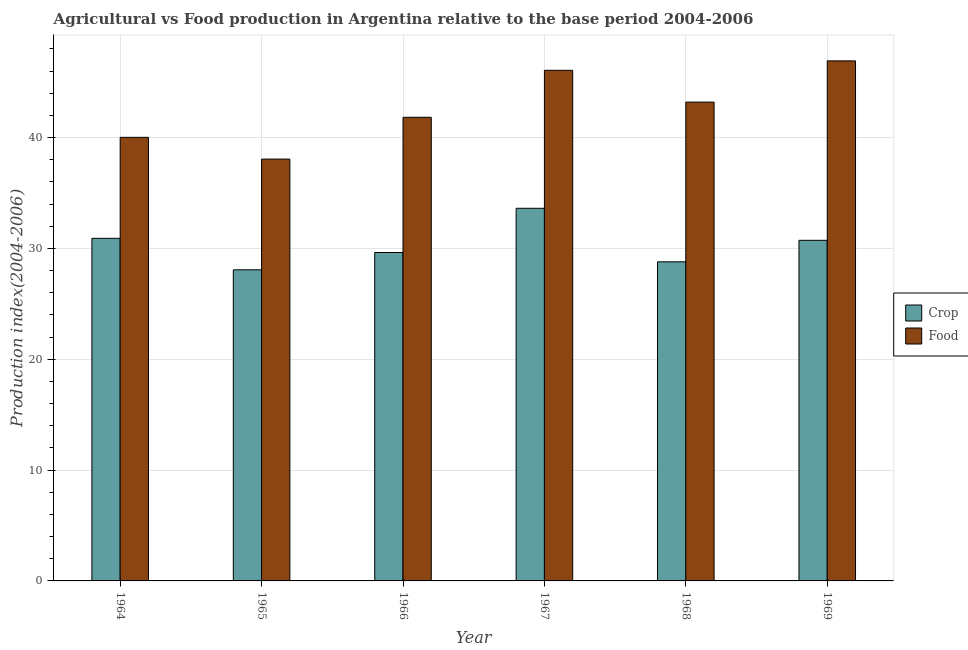Are the number of bars per tick equal to the number of legend labels?
Make the answer very short. Yes. How many bars are there on the 1st tick from the right?
Ensure brevity in your answer.  2. What is the label of the 1st group of bars from the left?
Give a very brief answer. 1964. What is the food production index in 1966?
Offer a very short reply. 41.83. Across all years, what is the maximum crop production index?
Ensure brevity in your answer.  33.62. Across all years, what is the minimum crop production index?
Provide a short and direct response. 28.07. In which year was the crop production index maximum?
Your response must be concise. 1967. In which year was the crop production index minimum?
Provide a succinct answer. 1965. What is the total crop production index in the graph?
Your answer should be compact. 181.75. What is the difference between the food production index in 1967 and that in 1969?
Keep it short and to the point. -0.85. What is the difference between the food production index in 1964 and the crop production index in 1965?
Offer a very short reply. 1.96. What is the average food production index per year?
Ensure brevity in your answer.  42.68. In the year 1968, what is the difference between the food production index and crop production index?
Your answer should be very brief. 0. What is the ratio of the food production index in 1968 to that in 1969?
Offer a terse response. 0.92. Is the difference between the crop production index in 1966 and 1968 greater than the difference between the food production index in 1966 and 1968?
Give a very brief answer. No. What is the difference between the highest and the second highest food production index?
Provide a succinct answer. 0.85. What is the difference between the highest and the lowest food production index?
Provide a succinct answer. 8.86. Is the sum of the food production index in 1964 and 1966 greater than the maximum crop production index across all years?
Your response must be concise. Yes. What does the 1st bar from the left in 1968 represents?
Your answer should be compact. Crop. What does the 1st bar from the right in 1967 represents?
Offer a terse response. Food. Are all the bars in the graph horizontal?
Make the answer very short. No. How many years are there in the graph?
Offer a terse response. 6. What is the difference between two consecutive major ticks on the Y-axis?
Give a very brief answer. 10. Are the values on the major ticks of Y-axis written in scientific E-notation?
Give a very brief answer. No. Does the graph contain grids?
Provide a short and direct response. Yes. What is the title of the graph?
Your response must be concise. Agricultural vs Food production in Argentina relative to the base period 2004-2006. What is the label or title of the X-axis?
Your answer should be compact. Year. What is the label or title of the Y-axis?
Provide a short and direct response. Production index(2004-2006). What is the Production index(2004-2006) in Crop in 1964?
Give a very brief answer. 30.91. What is the Production index(2004-2006) in Food in 1964?
Provide a short and direct response. 40.02. What is the Production index(2004-2006) of Crop in 1965?
Your answer should be very brief. 28.07. What is the Production index(2004-2006) in Food in 1965?
Your answer should be compact. 38.06. What is the Production index(2004-2006) of Crop in 1966?
Ensure brevity in your answer.  29.63. What is the Production index(2004-2006) of Food in 1966?
Provide a succinct answer. 41.83. What is the Production index(2004-2006) of Crop in 1967?
Offer a terse response. 33.62. What is the Production index(2004-2006) in Food in 1967?
Your answer should be very brief. 46.07. What is the Production index(2004-2006) of Crop in 1968?
Your response must be concise. 28.79. What is the Production index(2004-2006) in Food in 1968?
Keep it short and to the point. 43.2. What is the Production index(2004-2006) of Crop in 1969?
Offer a very short reply. 30.73. What is the Production index(2004-2006) of Food in 1969?
Your response must be concise. 46.92. Across all years, what is the maximum Production index(2004-2006) of Crop?
Make the answer very short. 33.62. Across all years, what is the maximum Production index(2004-2006) in Food?
Ensure brevity in your answer.  46.92. Across all years, what is the minimum Production index(2004-2006) in Crop?
Give a very brief answer. 28.07. Across all years, what is the minimum Production index(2004-2006) of Food?
Your answer should be compact. 38.06. What is the total Production index(2004-2006) of Crop in the graph?
Your answer should be compact. 181.75. What is the total Production index(2004-2006) of Food in the graph?
Your response must be concise. 256.1. What is the difference between the Production index(2004-2006) of Crop in 1964 and that in 1965?
Your response must be concise. 2.84. What is the difference between the Production index(2004-2006) in Food in 1964 and that in 1965?
Your answer should be very brief. 1.96. What is the difference between the Production index(2004-2006) in Crop in 1964 and that in 1966?
Make the answer very short. 1.28. What is the difference between the Production index(2004-2006) in Food in 1964 and that in 1966?
Your answer should be compact. -1.81. What is the difference between the Production index(2004-2006) of Crop in 1964 and that in 1967?
Provide a succinct answer. -2.71. What is the difference between the Production index(2004-2006) of Food in 1964 and that in 1967?
Ensure brevity in your answer.  -6.05. What is the difference between the Production index(2004-2006) in Crop in 1964 and that in 1968?
Make the answer very short. 2.12. What is the difference between the Production index(2004-2006) in Food in 1964 and that in 1968?
Keep it short and to the point. -3.18. What is the difference between the Production index(2004-2006) of Crop in 1964 and that in 1969?
Your answer should be compact. 0.18. What is the difference between the Production index(2004-2006) of Food in 1964 and that in 1969?
Ensure brevity in your answer.  -6.9. What is the difference between the Production index(2004-2006) in Crop in 1965 and that in 1966?
Provide a short and direct response. -1.56. What is the difference between the Production index(2004-2006) in Food in 1965 and that in 1966?
Provide a succinct answer. -3.77. What is the difference between the Production index(2004-2006) in Crop in 1965 and that in 1967?
Ensure brevity in your answer.  -5.55. What is the difference between the Production index(2004-2006) in Food in 1965 and that in 1967?
Your answer should be very brief. -8.01. What is the difference between the Production index(2004-2006) of Crop in 1965 and that in 1968?
Make the answer very short. -0.72. What is the difference between the Production index(2004-2006) in Food in 1965 and that in 1968?
Offer a terse response. -5.14. What is the difference between the Production index(2004-2006) in Crop in 1965 and that in 1969?
Your answer should be compact. -2.66. What is the difference between the Production index(2004-2006) of Food in 1965 and that in 1969?
Keep it short and to the point. -8.86. What is the difference between the Production index(2004-2006) of Crop in 1966 and that in 1967?
Ensure brevity in your answer.  -3.99. What is the difference between the Production index(2004-2006) of Food in 1966 and that in 1967?
Your answer should be compact. -4.24. What is the difference between the Production index(2004-2006) in Crop in 1966 and that in 1968?
Keep it short and to the point. 0.84. What is the difference between the Production index(2004-2006) of Food in 1966 and that in 1968?
Your response must be concise. -1.37. What is the difference between the Production index(2004-2006) of Food in 1966 and that in 1969?
Your answer should be compact. -5.09. What is the difference between the Production index(2004-2006) in Crop in 1967 and that in 1968?
Make the answer very short. 4.83. What is the difference between the Production index(2004-2006) of Food in 1967 and that in 1968?
Provide a succinct answer. 2.87. What is the difference between the Production index(2004-2006) of Crop in 1967 and that in 1969?
Offer a terse response. 2.89. What is the difference between the Production index(2004-2006) in Food in 1967 and that in 1969?
Provide a short and direct response. -0.85. What is the difference between the Production index(2004-2006) of Crop in 1968 and that in 1969?
Offer a very short reply. -1.94. What is the difference between the Production index(2004-2006) in Food in 1968 and that in 1969?
Provide a short and direct response. -3.72. What is the difference between the Production index(2004-2006) of Crop in 1964 and the Production index(2004-2006) of Food in 1965?
Your response must be concise. -7.15. What is the difference between the Production index(2004-2006) of Crop in 1964 and the Production index(2004-2006) of Food in 1966?
Make the answer very short. -10.92. What is the difference between the Production index(2004-2006) of Crop in 1964 and the Production index(2004-2006) of Food in 1967?
Your answer should be compact. -15.16. What is the difference between the Production index(2004-2006) in Crop in 1964 and the Production index(2004-2006) in Food in 1968?
Your answer should be compact. -12.29. What is the difference between the Production index(2004-2006) of Crop in 1964 and the Production index(2004-2006) of Food in 1969?
Provide a short and direct response. -16.01. What is the difference between the Production index(2004-2006) in Crop in 1965 and the Production index(2004-2006) in Food in 1966?
Keep it short and to the point. -13.76. What is the difference between the Production index(2004-2006) of Crop in 1965 and the Production index(2004-2006) of Food in 1968?
Your answer should be compact. -15.13. What is the difference between the Production index(2004-2006) in Crop in 1965 and the Production index(2004-2006) in Food in 1969?
Make the answer very short. -18.85. What is the difference between the Production index(2004-2006) of Crop in 1966 and the Production index(2004-2006) of Food in 1967?
Your answer should be compact. -16.44. What is the difference between the Production index(2004-2006) of Crop in 1966 and the Production index(2004-2006) of Food in 1968?
Your response must be concise. -13.57. What is the difference between the Production index(2004-2006) of Crop in 1966 and the Production index(2004-2006) of Food in 1969?
Offer a very short reply. -17.29. What is the difference between the Production index(2004-2006) of Crop in 1967 and the Production index(2004-2006) of Food in 1968?
Provide a succinct answer. -9.58. What is the difference between the Production index(2004-2006) of Crop in 1968 and the Production index(2004-2006) of Food in 1969?
Offer a terse response. -18.13. What is the average Production index(2004-2006) of Crop per year?
Provide a short and direct response. 30.29. What is the average Production index(2004-2006) of Food per year?
Keep it short and to the point. 42.68. In the year 1964, what is the difference between the Production index(2004-2006) in Crop and Production index(2004-2006) in Food?
Offer a very short reply. -9.11. In the year 1965, what is the difference between the Production index(2004-2006) in Crop and Production index(2004-2006) in Food?
Offer a terse response. -9.99. In the year 1966, what is the difference between the Production index(2004-2006) in Crop and Production index(2004-2006) in Food?
Your answer should be compact. -12.2. In the year 1967, what is the difference between the Production index(2004-2006) of Crop and Production index(2004-2006) of Food?
Ensure brevity in your answer.  -12.45. In the year 1968, what is the difference between the Production index(2004-2006) of Crop and Production index(2004-2006) of Food?
Your answer should be very brief. -14.41. In the year 1969, what is the difference between the Production index(2004-2006) in Crop and Production index(2004-2006) in Food?
Provide a succinct answer. -16.19. What is the ratio of the Production index(2004-2006) in Crop in 1964 to that in 1965?
Your answer should be very brief. 1.1. What is the ratio of the Production index(2004-2006) of Food in 1964 to that in 1965?
Provide a short and direct response. 1.05. What is the ratio of the Production index(2004-2006) of Crop in 1964 to that in 1966?
Ensure brevity in your answer.  1.04. What is the ratio of the Production index(2004-2006) of Food in 1964 to that in 1966?
Ensure brevity in your answer.  0.96. What is the ratio of the Production index(2004-2006) in Crop in 1964 to that in 1967?
Offer a terse response. 0.92. What is the ratio of the Production index(2004-2006) of Food in 1964 to that in 1967?
Make the answer very short. 0.87. What is the ratio of the Production index(2004-2006) of Crop in 1964 to that in 1968?
Your answer should be compact. 1.07. What is the ratio of the Production index(2004-2006) of Food in 1964 to that in 1968?
Give a very brief answer. 0.93. What is the ratio of the Production index(2004-2006) of Crop in 1964 to that in 1969?
Ensure brevity in your answer.  1.01. What is the ratio of the Production index(2004-2006) in Food in 1964 to that in 1969?
Offer a very short reply. 0.85. What is the ratio of the Production index(2004-2006) in Food in 1965 to that in 1966?
Keep it short and to the point. 0.91. What is the ratio of the Production index(2004-2006) in Crop in 1965 to that in 1967?
Your answer should be very brief. 0.83. What is the ratio of the Production index(2004-2006) in Food in 1965 to that in 1967?
Keep it short and to the point. 0.83. What is the ratio of the Production index(2004-2006) in Food in 1965 to that in 1968?
Make the answer very short. 0.88. What is the ratio of the Production index(2004-2006) in Crop in 1965 to that in 1969?
Provide a short and direct response. 0.91. What is the ratio of the Production index(2004-2006) of Food in 1965 to that in 1969?
Make the answer very short. 0.81. What is the ratio of the Production index(2004-2006) of Crop in 1966 to that in 1967?
Make the answer very short. 0.88. What is the ratio of the Production index(2004-2006) in Food in 1966 to that in 1967?
Make the answer very short. 0.91. What is the ratio of the Production index(2004-2006) in Crop in 1966 to that in 1968?
Offer a terse response. 1.03. What is the ratio of the Production index(2004-2006) of Food in 1966 to that in 1968?
Give a very brief answer. 0.97. What is the ratio of the Production index(2004-2006) of Crop in 1966 to that in 1969?
Provide a succinct answer. 0.96. What is the ratio of the Production index(2004-2006) in Food in 1966 to that in 1969?
Provide a short and direct response. 0.89. What is the ratio of the Production index(2004-2006) of Crop in 1967 to that in 1968?
Your answer should be very brief. 1.17. What is the ratio of the Production index(2004-2006) of Food in 1967 to that in 1968?
Your answer should be compact. 1.07. What is the ratio of the Production index(2004-2006) of Crop in 1967 to that in 1969?
Your response must be concise. 1.09. What is the ratio of the Production index(2004-2006) in Food in 1967 to that in 1969?
Make the answer very short. 0.98. What is the ratio of the Production index(2004-2006) of Crop in 1968 to that in 1969?
Your response must be concise. 0.94. What is the ratio of the Production index(2004-2006) in Food in 1968 to that in 1969?
Offer a terse response. 0.92. What is the difference between the highest and the second highest Production index(2004-2006) in Crop?
Offer a terse response. 2.71. What is the difference between the highest and the second highest Production index(2004-2006) in Food?
Provide a short and direct response. 0.85. What is the difference between the highest and the lowest Production index(2004-2006) of Crop?
Your response must be concise. 5.55. What is the difference between the highest and the lowest Production index(2004-2006) of Food?
Make the answer very short. 8.86. 